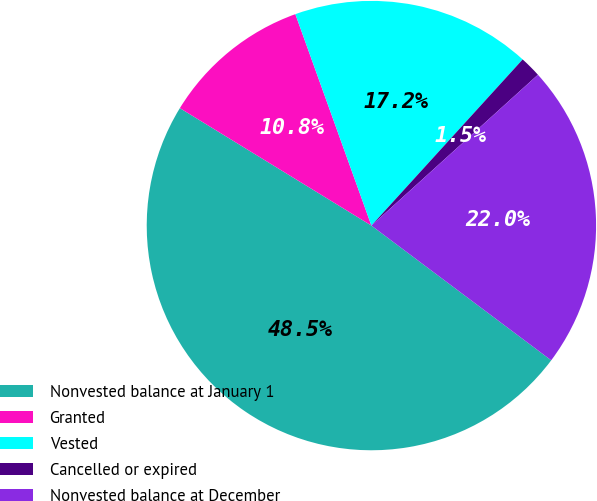<chart> <loc_0><loc_0><loc_500><loc_500><pie_chart><fcel>Nonvested balance at January 1<fcel>Granted<fcel>Vested<fcel>Cancelled or expired<fcel>Nonvested balance at December<nl><fcel>48.52%<fcel>10.75%<fcel>17.25%<fcel>1.53%<fcel>21.95%<nl></chart> 